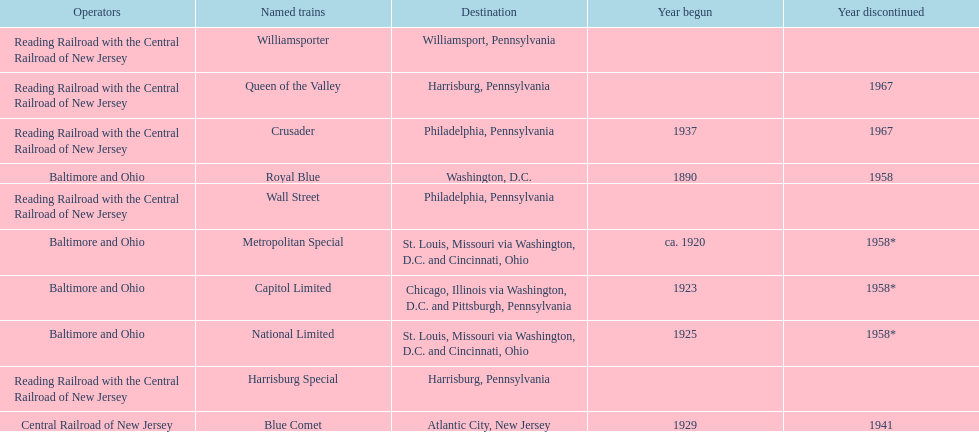What destination is at the top of the list? Chicago, Illinois via Washington, D.C. and Pittsburgh, Pennsylvania. 